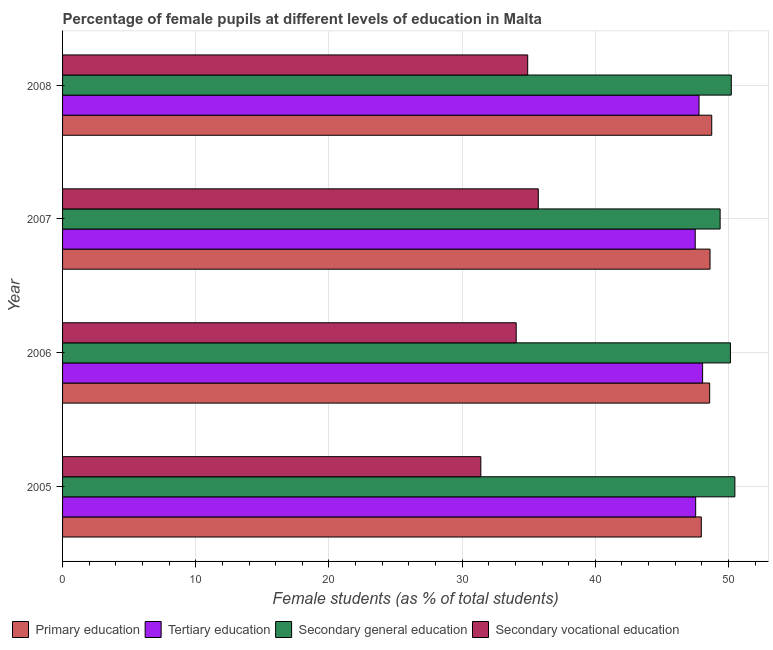How many groups of bars are there?
Offer a terse response. 4. Are the number of bars per tick equal to the number of legend labels?
Offer a terse response. Yes. Are the number of bars on each tick of the Y-axis equal?
Your answer should be very brief. Yes. How many bars are there on the 2nd tick from the bottom?
Your response must be concise. 4. What is the label of the 2nd group of bars from the top?
Your answer should be compact. 2007. In how many cases, is the number of bars for a given year not equal to the number of legend labels?
Offer a very short reply. 0. What is the percentage of female students in primary education in 2005?
Your answer should be very brief. 47.96. Across all years, what is the maximum percentage of female students in tertiary education?
Give a very brief answer. 48.06. Across all years, what is the minimum percentage of female students in tertiary education?
Your response must be concise. 47.51. What is the total percentage of female students in secondary education in the graph?
Your answer should be very brief. 200.22. What is the difference between the percentage of female students in secondary education in 2005 and that in 2008?
Your answer should be very brief. 0.27. What is the difference between the percentage of female students in primary education in 2006 and the percentage of female students in secondary education in 2008?
Offer a very short reply. -1.62. What is the average percentage of female students in secondary vocational education per year?
Provide a short and direct response. 34.03. In the year 2007, what is the difference between the percentage of female students in secondary vocational education and percentage of female students in primary education?
Your answer should be very brief. -12.89. What is the ratio of the percentage of female students in secondary vocational education in 2005 to that in 2006?
Provide a short and direct response. 0.92. Is the difference between the percentage of female students in primary education in 2005 and 2008 greater than the difference between the percentage of female students in secondary vocational education in 2005 and 2008?
Provide a short and direct response. Yes. What is the difference between the highest and the second highest percentage of female students in tertiary education?
Your response must be concise. 0.27. What is the difference between the highest and the lowest percentage of female students in tertiary education?
Ensure brevity in your answer.  0.56. In how many years, is the percentage of female students in secondary vocational education greater than the average percentage of female students in secondary vocational education taken over all years?
Offer a terse response. 3. What does the 1st bar from the top in 2008 represents?
Offer a terse response. Secondary vocational education. What does the 4th bar from the bottom in 2007 represents?
Provide a short and direct response. Secondary vocational education. Is it the case that in every year, the sum of the percentage of female students in primary education and percentage of female students in tertiary education is greater than the percentage of female students in secondary education?
Offer a terse response. Yes. Are all the bars in the graph horizontal?
Your answer should be compact. Yes. How many years are there in the graph?
Provide a short and direct response. 4. What is the difference between two consecutive major ticks on the X-axis?
Provide a short and direct response. 10. Does the graph contain any zero values?
Offer a very short reply. No. Where does the legend appear in the graph?
Make the answer very short. Bottom left. How are the legend labels stacked?
Keep it short and to the point. Horizontal. What is the title of the graph?
Provide a short and direct response. Percentage of female pupils at different levels of education in Malta. What is the label or title of the X-axis?
Offer a very short reply. Female students (as % of total students). What is the label or title of the Y-axis?
Provide a short and direct response. Year. What is the Female students (as % of total students) in Primary education in 2005?
Provide a succinct answer. 47.96. What is the Female students (as % of total students) in Tertiary education in 2005?
Your answer should be very brief. 47.54. What is the Female students (as % of total students) of Secondary general education in 2005?
Your answer should be very brief. 50.48. What is the Female students (as % of total students) of Secondary vocational education in 2005?
Offer a very short reply. 31.41. What is the Female students (as % of total students) of Primary education in 2006?
Offer a very short reply. 48.59. What is the Female students (as % of total students) in Tertiary education in 2006?
Your response must be concise. 48.06. What is the Female students (as % of total students) in Secondary general education in 2006?
Offer a very short reply. 50.15. What is the Female students (as % of total students) of Secondary vocational education in 2006?
Make the answer very short. 34.06. What is the Female students (as % of total students) of Primary education in 2007?
Give a very brief answer. 48.62. What is the Female students (as % of total students) of Tertiary education in 2007?
Ensure brevity in your answer.  47.51. What is the Female students (as % of total students) of Secondary general education in 2007?
Your response must be concise. 49.38. What is the Female students (as % of total students) in Secondary vocational education in 2007?
Offer a terse response. 35.72. What is the Female students (as % of total students) in Primary education in 2008?
Offer a very short reply. 48.74. What is the Female students (as % of total students) of Tertiary education in 2008?
Offer a very short reply. 47.79. What is the Female students (as % of total students) of Secondary general education in 2008?
Ensure brevity in your answer.  50.21. What is the Female students (as % of total students) of Secondary vocational education in 2008?
Give a very brief answer. 34.93. Across all years, what is the maximum Female students (as % of total students) in Primary education?
Keep it short and to the point. 48.74. Across all years, what is the maximum Female students (as % of total students) in Tertiary education?
Your answer should be compact. 48.06. Across all years, what is the maximum Female students (as % of total students) of Secondary general education?
Your response must be concise. 50.48. Across all years, what is the maximum Female students (as % of total students) in Secondary vocational education?
Offer a terse response. 35.72. Across all years, what is the minimum Female students (as % of total students) of Primary education?
Your answer should be compact. 47.96. Across all years, what is the minimum Female students (as % of total students) in Tertiary education?
Your answer should be very brief. 47.51. Across all years, what is the minimum Female students (as % of total students) in Secondary general education?
Offer a very short reply. 49.38. Across all years, what is the minimum Female students (as % of total students) of Secondary vocational education?
Ensure brevity in your answer.  31.41. What is the total Female students (as % of total students) of Primary education in the graph?
Your answer should be very brief. 193.91. What is the total Female students (as % of total students) of Tertiary education in the graph?
Your answer should be very brief. 190.9. What is the total Female students (as % of total students) of Secondary general education in the graph?
Your answer should be very brief. 200.22. What is the total Female students (as % of total students) in Secondary vocational education in the graph?
Provide a succinct answer. 136.12. What is the difference between the Female students (as % of total students) in Primary education in 2005 and that in 2006?
Keep it short and to the point. -0.63. What is the difference between the Female students (as % of total students) of Tertiary education in 2005 and that in 2006?
Offer a very short reply. -0.52. What is the difference between the Female students (as % of total students) of Secondary general education in 2005 and that in 2006?
Provide a short and direct response. 0.33. What is the difference between the Female students (as % of total students) in Secondary vocational education in 2005 and that in 2006?
Your answer should be compact. -2.66. What is the difference between the Female students (as % of total students) in Primary education in 2005 and that in 2007?
Make the answer very short. -0.65. What is the difference between the Female students (as % of total students) of Tertiary education in 2005 and that in 2007?
Provide a short and direct response. 0.03. What is the difference between the Female students (as % of total students) of Secondary general education in 2005 and that in 2007?
Offer a terse response. 1.11. What is the difference between the Female students (as % of total students) of Secondary vocational education in 2005 and that in 2007?
Your answer should be very brief. -4.32. What is the difference between the Female students (as % of total students) of Primary education in 2005 and that in 2008?
Provide a short and direct response. -0.78. What is the difference between the Female students (as % of total students) in Tertiary education in 2005 and that in 2008?
Your answer should be very brief. -0.25. What is the difference between the Female students (as % of total students) in Secondary general education in 2005 and that in 2008?
Provide a short and direct response. 0.27. What is the difference between the Female students (as % of total students) in Secondary vocational education in 2005 and that in 2008?
Your response must be concise. -3.52. What is the difference between the Female students (as % of total students) in Primary education in 2006 and that in 2007?
Provide a short and direct response. -0.03. What is the difference between the Female students (as % of total students) of Tertiary education in 2006 and that in 2007?
Your answer should be compact. 0.56. What is the difference between the Female students (as % of total students) in Secondary general education in 2006 and that in 2007?
Keep it short and to the point. 0.77. What is the difference between the Female students (as % of total students) in Secondary vocational education in 2006 and that in 2007?
Provide a succinct answer. -1.66. What is the difference between the Female students (as % of total students) in Primary education in 2006 and that in 2008?
Ensure brevity in your answer.  -0.16. What is the difference between the Female students (as % of total students) in Tertiary education in 2006 and that in 2008?
Provide a short and direct response. 0.27. What is the difference between the Female students (as % of total students) in Secondary general education in 2006 and that in 2008?
Provide a short and direct response. -0.07. What is the difference between the Female students (as % of total students) in Secondary vocational education in 2006 and that in 2008?
Offer a terse response. -0.86. What is the difference between the Female students (as % of total students) of Primary education in 2007 and that in 2008?
Offer a very short reply. -0.13. What is the difference between the Female students (as % of total students) in Tertiary education in 2007 and that in 2008?
Offer a very short reply. -0.29. What is the difference between the Female students (as % of total students) in Secondary general education in 2007 and that in 2008?
Offer a terse response. -0.84. What is the difference between the Female students (as % of total students) in Secondary vocational education in 2007 and that in 2008?
Give a very brief answer. 0.8. What is the difference between the Female students (as % of total students) of Primary education in 2005 and the Female students (as % of total students) of Tertiary education in 2006?
Your answer should be compact. -0.1. What is the difference between the Female students (as % of total students) in Primary education in 2005 and the Female students (as % of total students) in Secondary general education in 2006?
Provide a succinct answer. -2.19. What is the difference between the Female students (as % of total students) in Primary education in 2005 and the Female students (as % of total students) in Secondary vocational education in 2006?
Keep it short and to the point. 13.9. What is the difference between the Female students (as % of total students) of Tertiary education in 2005 and the Female students (as % of total students) of Secondary general education in 2006?
Your response must be concise. -2.61. What is the difference between the Female students (as % of total students) of Tertiary education in 2005 and the Female students (as % of total students) of Secondary vocational education in 2006?
Provide a short and direct response. 13.48. What is the difference between the Female students (as % of total students) of Secondary general education in 2005 and the Female students (as % of total students) of Secondary vocational education in 2006?
Your answer should be compact. 16.42. What is the difference between the Female students (as % of total students) of Primary education in 2005 and the Female students (as % of total students) of Tertiary education in 2007?
Provide a short and direct response. 0.46. What is the difference between the Female students (as % of total students) in Primary education in 2005 and the Female students (as % of total students) in Secondary general education in 2007?
Your answer should be very brief. -1.41. What is the difference between the Female students (as % of total students) of Primary education in 2005 and the Female students (as % of total students) of Secondary vocational education in 2007?
Provide a succinct answer. 12.24. What is the difference between the Female students (as % of total students) of Tertiary education in 2005 and the Female students (as % of total students) of Secondary general education in 2007?
Provide a succinct answer. -1.84. What is the difference between the Female students (as % of total students) in Tertiary education in 2005 and the Female students (as % of total students) in Secondary vocational education in 2007?
Your response must be concise. 11.82. What is the difference between the Female students (as % of total students) of Secondary general education in 2005 and the Female students (as % of total students) of Secondary vocational education in 2007?
Offer a very short reply. 14.76. What is the difference between the Female students (as % of total students) in Primary education in 2005 and the Female students (as % of total students) in Tertiary education in 2008?
Ensure brevity in your answer.  0.17. What is the difference between the Female students (as % of total students) of Primary education in 2005 and the Female students (as % of total students) of Secondary general education in 2008?
Give a very brief answer. -2.25. What is the difference between the Female students (as % of total students) of Primary education in 2005 and the Female students (as % of total students) of Secondary vocational education in 2008?
Offer a terse response. 13.04. What is the difference between the Female students (as % of total students) of Tertiary education in 2005 and the Female students (as % of total students) of Secondary general education in 2008?
Ensure brevity in your answer.  -2.67. What is the difference between the Female students (as % of total students) of Tertiary education in 2005 and the Female students (as % of total students) of Secondary vocational education in 2008?
Ensure brevity in your answer.  12.61. What is the difference between the Female students (as % of total students) in Secondary general education in 2005 and the Female students (as % of total students) in Secondary vocational education in 2008?
Provide a succinct answer. 15.56. What is the difference between the Female students (as % of total students) in Primary education in 2006 and the Female students (as % of total students) in Tertiary education in 2007?
Provide a short and direct response. 1.08. What is the difference between the Female students (as % of total students) of Primary education in 2006 and the Female students (as % of total students) of Secondary general education in 2007?
Your answer should be very brief. -0.79. What is the difference between the Female students (as % of total students) of Primary education in 2006 and the Female students (as % of total students) of Secondary vocational education in 2007?
Provide a short and direct response. 12.87. What is the difference between the Female students (as % of total students) of Tertiary education in 2006 and the Female students (as % of total students) of Secondary general education in 2007?
Your answer should be very brief. -1.31. What is the difference between the Female students (as % of total students) in Tertiary education in 2006 and the Female students (as % of total students) in Secondary vocational education in 2007?
Provide a succinct answer. 12.34. What is the difference between the Female students (as % of total students) of Secondary general education in 2006 and the Female students (as % of total students) of Secondary vocational education in 2007?
Offer a very short reply. 14.43. What is the difference between the Female students (as % of total students) in Primary education in 2006 and the Female students (as % of total students) in Tertiary education in 2008?
Your answer should be very brief. 0.8. What is the difference between the Female students (as % of total students) in Primary education in 2006 and the Female students (as % of total students) in Secondary general education in 2008?
Provide a short and direct response. -1.62. What is the difference between the Female students (as % of total students) of Primary education in 2006 and the Female students (as % of total students) of Secondary vocational education in 2008?
Give a very brief answer. 13.66. What is the difference between the Female students (as % of total students) of Tertiary education in 2006 and the Female students (as % of total students) of Secondary general education in 2008?
Provide a short and direct response. -2.15. What is the difference between the Female students (as % of total students) of Tertiary education in 2006 and the Female students (as % of total students) of Secondary vocational education in 2008?
Provide a succinct answer. 13.13. What is the difference between the Female students (as % of total students) of Secondary general education in 2006 and the Female students (as % of total students) of Secondary vocational education in 2008?
Offer a terse response. 15.22. What is the difference between the Female students (as % of total students) of Primary education in 2007 and the Female students (as % of total students) of Tertiary education in 2008?
Offer a terse response. 0.82. What is the difference between the Female students (as % of total students) of Primary education in 2007 and the Female students (as % of total students) of Secondary general education in 2008?
Make the answer very short. -1.6. What is the difference between the Female students (as % of total students) in Primary education in 2007 and the Female students (as % of total students) in Secondary vocational education in 2008?
Give a very brief answer. 13.69. What is the difference between the Female students (as % of total students) of Tertiary education in 2007 and the Female students (as % of total students) of Secondary general education in 2008?
Ensure brevity in your answer.  -2.71. What is the difference between the Female students (as % of total students) in Tertiary education in 2007 and the Female students (as % of total students) in Secondary vocational education in 2008?
Your response must be concise. 12.58. What is the difference between the Female students (as % of total students) in Secondary general education in 2007 and the Female students (as % of total students) in Secondary vocational education in 2008?
Give a very brief answer. 14.45. What is the average Female students (as % of total students) in Primary education per year?
Your answer should be compact. 48.48. What is the average Female students (as % of total students) of Tertiary education per year?
Your response must be concise. 47.72. What is the average Female students (as % of total students) of Secondary general education per year?
Your response must be concise. 50.06. What is the average Female students (as % of total students) in Secondary vocational education per year?
Provide a succinct answer. 34.03. In the year 2005, what is the difference between the Female students (as % of total students) in Primary education and Female students (as % of total students) in Tertiary education?
Make the answer very short. 0.42. In the year 2005, what is the difference between the Female students (as % of total students) in Primary education and Female students (as % of total students) in Secondary general education?
Keep it short and to the point. -2.52. In the year 2005, what is the difference between the Female students (as % of total students) of Primary education and Female students (as % of total students) of Secondary vocational education?
Offer a very short reply. 16.56. In the year 2005, what is the difference between the Female students (as % of total students) in Tertiary education and Female students (as % of total students) in Secondary general education?
Offer a very short reply. -2.94. In the year 2005, what is the difference between the Female students (as % of total students) in Tertiary education and Female students (as % of total students) in Secondary vocational education?
Provide a succinct answer. 16.13. In the year 2005, what is the difference between the Female students (as % of total students) in Secondary general education and Female students (as % of total students) in Secondary vocational education?
Make the answer very short. 19.08. In the year 2006, what is the difference between the Female students (as % of total students) of Primary education and Female students (as % of total students) of Tertiary education?
Ensure brevity in your answer.  0.53. In the year 2006, what is the difference between the Female students (as % of total students) in Primary education and Female students (as % of total students) in Secondary general education?
Your response must be concise. -1.56. In the year 2006, what is the difference between the Female students (as % of total students) in Primary education and Female students (as % of total students) in Secondary vocational education?
Offer a terse response. 14.53. In the year 2006, what is the difference between the Female students (as % of total students) in Tertiary education and Female students (as % of total students) in Secondary general education?
Ensure brevity in your answer.  -2.09. In the year 2006, what is the difference between the Female students (as % of total students) in Tertiary education and Female students (as % of total students) in Secondary vocational education?
Your answer should be compact. 14. In the year 2006, what is the difference between the Female students (as % of total students) in Secondary general education and Female students (as % of total students) in Secondary vocational education?
Provide a short and direct response. 16.08. In the year 2007, what is the difference between the Female students (as % of total students) in Primary education and Female students (as % of total students) in Tertiary education?
Give a very brief answer. 1.11. In the year 2007, what is the difference between the Female students (as % of total students) in Primary education and Female students (as % of total students) in Secondary general education?
Make the answer very short. -0.76. In the year 2007, what is the difference between the Female students (as % of total students) in Primary education and Female students (as % of total students) in Secondary vocational education?
Provide a succinct answer. 12.89. In the year 2007, what is the difference between the Female students (as % of total students) in Tertiary education and Female students (as % of total students) in Secondary general education?
Your response must be concise. -1.87. In the year 2007, what is the difference between the Female students (as % of total students) in Tertiary education and Female students (as % of total students) in Secondary vocational education?
Offer a very short reply. 11.78. In the year 2007, what is the difference between the Female students (as % of total students) in Secondary general education and Female students (as % of total students) in Secondary vocational education?
Your response must be concise. 13.65. In the year 2008, what is the difference between the Female students (as % of total students) in Primary education and Female students (as % of total students) in Tertiary education?
Give a very brief answer. 0.95. In the year 2008, what is the difference between the Female students (as % of total students) of Primary education and Female students (as % of total students) of Secondary general education?
Give a very brief answer. -1.47. In the year 2008, what is the difference between the Female students (as % of total students) of Primary education and Female students (as % of total students) of Secondary vocational education?
Offer a very short reply. 13.82. In the year 2008, what is the difference between the Female students (as % of total students) in Tertiary education and Female students (as % of total students) in Secondary general education?
Provide a short and direct response. -2.42. In the year 2008, what is the difference between the Female students (as % of total students) of Tertiary education and Female students (as % of total students) of Secondary vocational education?
Ensure brevity in your answer.  12.87. In the year 2008, what is the difference between the Female students (as % of total students) of Secondary general education and Female students (as % of total students) of Secondary vocational education?
Your answer should be compact. 15.29. What is the ratio of the Female students (as % of total students) of Primary education in 2005 to that in 2006?
Your response must be concise. 0.99. What is the ratio of the Female students (as % of total students) in Secondary vocational education in 2005 to that in 2006?
Your answer should be very brief. 0.92. What is the ratio of the Female students (as % of total students) in Primary education in 2005 to that in 2007?
Make the answer very short. 0.99. What is the ratio of the Female students (as % of total students) of Secondary general education in 2005 to that in 2007?
Offer a very short reply. 1.02. What is the ratio of the Female students (as % of total students) in Secondary vocational education in 2005 to that in 2007?
Keep it short and to the point. 0.88. What is the ratio of the Female students (as % of total students) in Primary education in 2005 to that in 2008?
Offer a terse response. 0.98. What is the ratio of the Female students (as % of total students) of Secondary general education in 2005 to that in 2008?
Offer a terse response. 1.01. What is the ratio of the Female students (as % of total students) of Secondary vocational education in 2005 to that in 2008?
Offer a terse response. 0.9. What is the ratio of the Female students (as % of total students) in Tertiary education in 2006 to that in 2007?
Offer a terse response. 1.01. What is the ratio of the Female students (as % of total students) of Secondary general education in 2006 to that in 2007?
Give a very brief answer. 1.02. What is the ratio of the Female students (as % of total students) of Secondary vocational education in 2006 to that in 2007?
Your answer should be compact. 0.95. What is the ratio of the Female students (as % of total students) in Tertiary education in 2006 to that in 2008?
Provide a succinct answer. 1.01. What is the ratio of the Female students (as % of total students) in Secondary vocational education in 2006 to that in 2008?
Your response must be concise. 0.98. What is the ratio of the Female students (as % of total students) of Primary education in 2007 to that in 2008?
Give a very brief answer. 1. What is the ratio of the Female students (as % of total students) of Secondary general education in 2007 to that in 2008?
Offer a very short reply. 0.98. What is the ratio of the Female students (as % of total students) of Secondary vocational education in 2007 to that in 2008?
Provide a succinct answer. 1.02. What is the difference between the highest and the second highest Female students (as % of total students) of Primary education?
Your answer should be very brief. 0.13. What is the difference between the highest and the second highest Female students (as % of total students) in Tertiary education?
Provide a succinct answer. 0.27. What is the difference between the highest and the second highest Female students (as % of total students) in Secondary general education?
Keep it short and to the point. 0.27. What is the difference between the highest and the second highest Female students (as % of total students) of Secondary vocational education?
Make the answer very short. 0.8. What is the difference between the highest and the lowest Female students (as % of total students) of Primary education?
Your response must be concise. 0.78. What is the difference between the highest and the lowest Female students (as % of total students) of Tertiary education?
Your answer should be very brief. 0.56. What is the difference between the highest and the lowest Female students (as % of total students) of Secondary general education?
Offer a terse response. 1.11. What is the difference between the highest and the lowest Female students (as % of total students) in Secondary vocational education?
Your response must be concise. 4.32. 